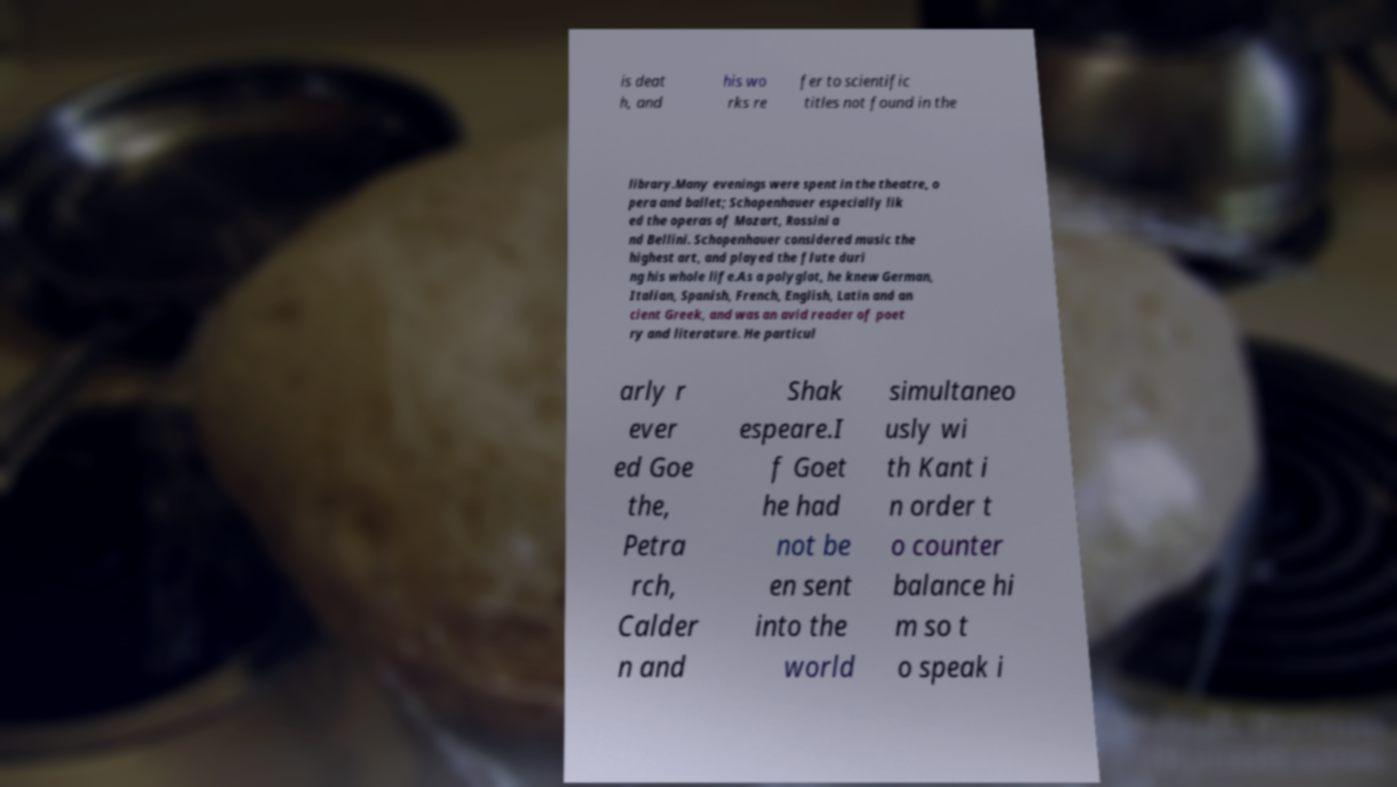Can you read and provide the text displayed in the image?This photo seems to have some interesting text. Can you extract and type it out for me? is deat h, and his wo rks re fer to scientific titles not found in the library.Many evenings were spent in the theatre, o pera and ballet; Schopenhauer especially lik ed the operas of Mozart, Rossini a nd Bellini. Schopenhauer considered music the highest art, and played the flute duri ng his whole life.As a polyglot, he knew German, Italian, Spanish, French, English, Latin and an cient Greek, and was an avid reader of poet ry and literature. He particul arly r ever ed Goe the, Petra rch, Calder n and Shak espeare.I f Goet he had not be en sent into the world simultaneo usly wi th Kant i n order t o counter balance hi m so t o speak i 